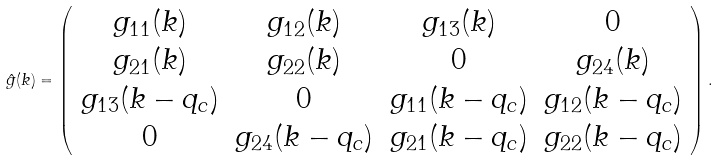<formula> <loc_0><loc_0><loc_500><loc_500>\hat { g } ( k ) = \left ( \begin{array} { c c c c } g _ { 1 1 } ( k ) & g _ { 1 2 } ( k ) & g _ { 1 3 } ( k ) & 0 \\ g _ { 2 1 } ( k ) & g _ { 2 2 } ( k ) & 0 & g _ { 2 4 } ( k ) \\ g _ { 1 3 } ( k - q _ { c } ) & 0 & g _ { 1 1 } ( k - q _ { c } ) & g _ { 1 2 } ( k - q _ { c } ) \\ 0 & g _ { 2 4 } ( k - q _ { c } ) & g _ { 2 1 } ( k - q _ { c } ) & g _ { 2 2 } ( k - q _ { c } ) \end{array} \right ) .</formula> 